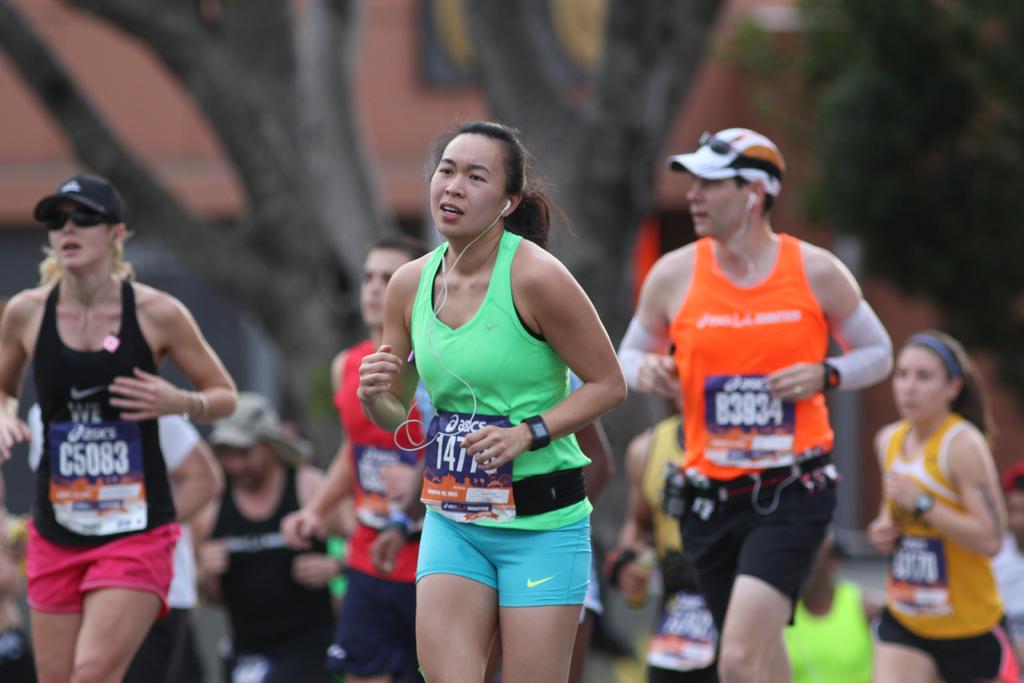What is the number of the runner in black?
Your answer should be very brief. C5083. 